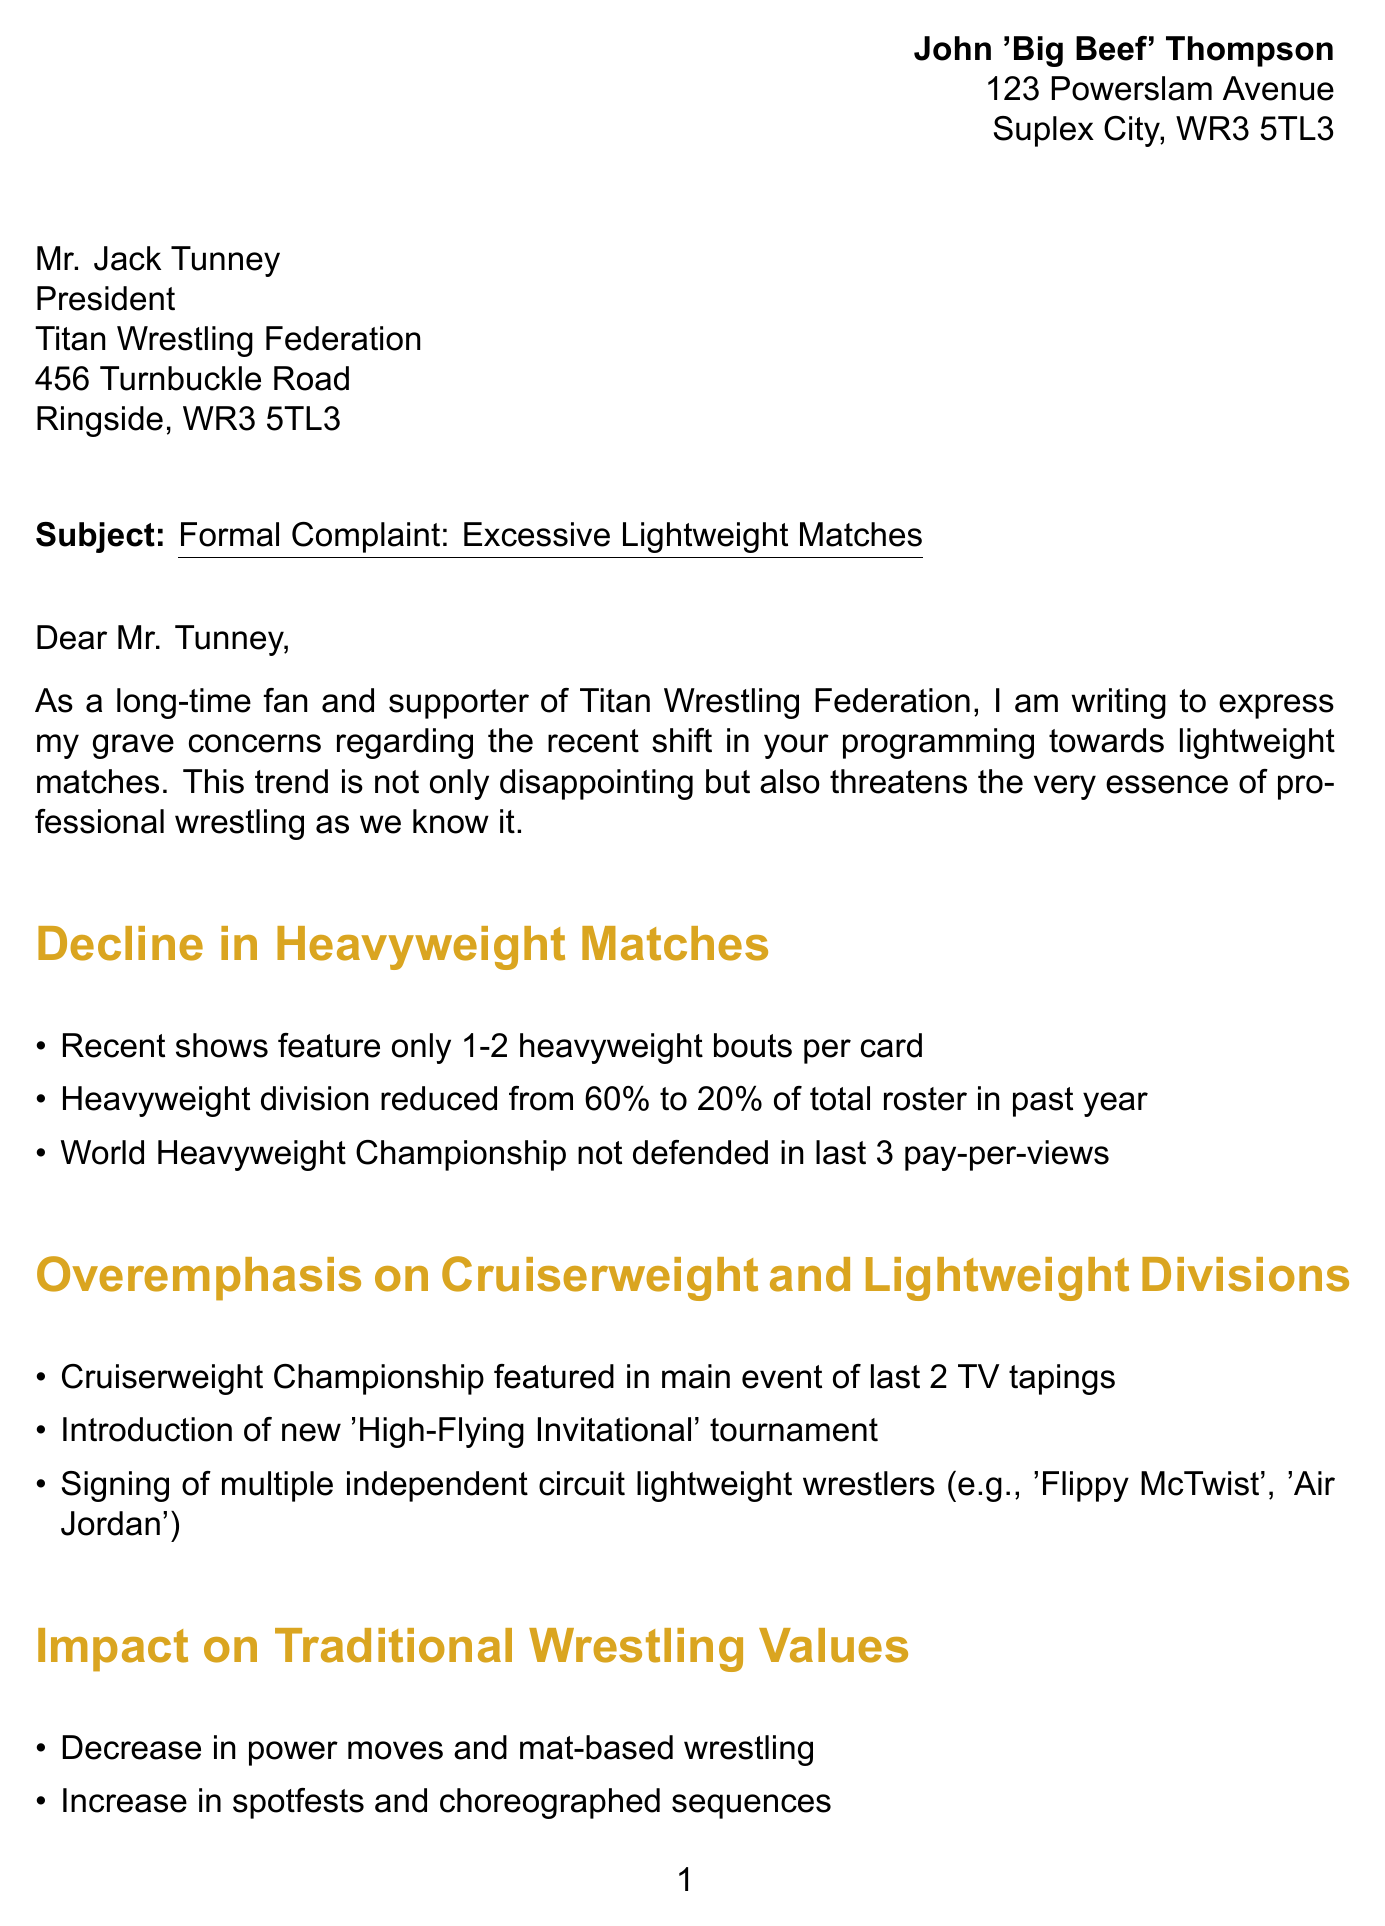What is the sender's name? The sender is identified at the beginning of the document with the name John 'Big Beef' Thompson.
Answer: John 'Big Beef' Thompson What is the subject of the complaint? The subject is stated clearly in the document and reflects the main concern addressed in the letter.
Answer: Formal Complaint: Excessive Lightweight Matches How many heavyweight bouts were featured in recent shows? The letter specifies that there are only 1-2 heavyweight bouts per card in recent shows.
Answer: 1-2 What percentage of the roster is now heavyweight wrestlers? The document notes that the heavyweight division has been reduced to 20% of the total roster.
Answer: 20% What does the sender expect within 30 days? The sender mentions a specific expectation for a written response to their concerns within a certain timeframe.
Answer: Written response What are the proposed solutions to the complaint? The letter lists several solutions that the sender believes would help address the issue raised.
Answer: Increase heavyweight matches to at least 50% of each card What is referenced as a reason for fan dissatisfaction? The document points to a decline in attendance at live events as a key factor in fan dissatisfaction.
Answer: Decline in attendance Which promotion is cited as a relevant example from the 1980s-1990s? The letter references a well-known promotion that had a successful focus on heavyweight wrestlers during that era.
Answer: World Wrestling Federation (WWF) What may happen if the concerns are not addressed? The letter concludes with a potential consequence if the organization does not respond to the complaint satisfactorily.
Answer: Potential boycott of future events 